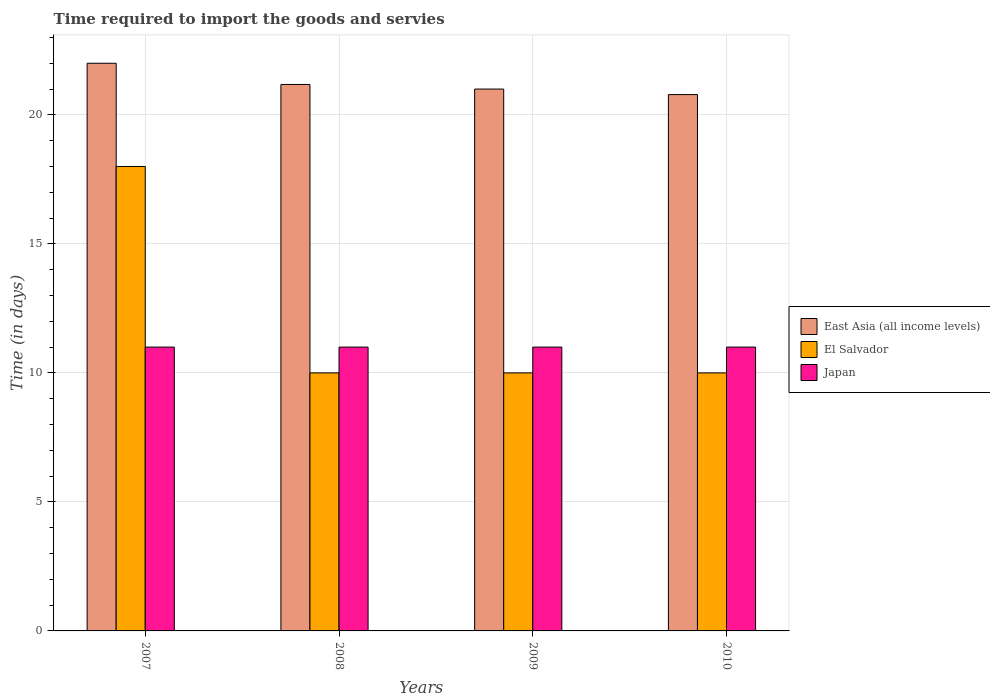How many groups of bars are there?
Offer a terse response. 4. Are the number of bars per tick equal to the number of legend labels?
Your response must be concise. Yes. Are the number of bars on each tick of the X-axis equal?
Offer a very short reply. Yes. How many bars are there on the 4th tick from the left?
Give a very brief answer. 3. How many bars are there on the 2nd tick from the right?
Your answer should be very brief. 3. Across all years, what is the maximum number of days required to import the goods and services in Japan?
Provide a succinct answer. 11. Across all years, what is the minimum number of days required to import the goods and services in Japan?
Give a very brief answer. 11. What is the total number of days required to import the goods and services in Japan in the graph?
Provide a succinct answer. 44. What is the difference between the number of days required to import the goods and services in El Salvador in 2008 and the number of days required to import the goods and services in Japan in 2007?
Provide a short and direct response. -1. What is the average number of days required to import the goods and services in El Salvador per year?
Offer a very short reply. 12. In the year 2010, what is the difference between the number of days required to import the goods and services in El Salvador and number of days required to import the goods and services in East Asia (all income levels)?
Provide a short and direct response. -10.79. In how many years, is the number of days required to import the goods and services in East Asia (all income levels) greater than 7 days?
Your answer should be very brief. 4. What is the ratio of the number of days required to import the goods and services in El Salvador in 2007 to that in 2010?
Offer a terse response. 1.8. What is the difference between the highest and the lowest number of days required to import the goods and services in El Salvador?
Provide a short and direct response. 8. In how many years, is the number of days required to import the goods and services in Japan greater than the average number of days required to import the goods and services in Japan taken over all years?
Make the answer very short. 0. What does the 2nd bar from the left in 2009 represents?
Your response must be concise. El Salvador. What does the 1st bar from the right in 2008 represents?
Keep it short and to the point. Japan. Is it the case that in every year, the sum of the number of days required to import the goods and services in East Asia (all income levels) and number of days required to import the goods and services in El Salvador is greater than the number of days required to import the goods and services in Japan?
Make the answer very short. Yes. How many bars are there?
Offer a terse response. 12. Are all the bars in the graph horizontal?
Provide a short and direct response. No. How many years are there in the graph?
Ensure brevity in your answer.  4. What is the difference between two consecutive major ticks on the Y-axis?
Ensure brevity in your answer.  5. Are the values on the major ticks of Y-axis written in scientific E-notation?
Give a very brief answer. No. Does the graph contain grids?
Provide a succinct answer. Yes. Where does the legend appear in the graph?
Keep it short and to the point. Center right. How are the legend labels stacked?
Offer a very short reply. Vertical. What is the title of the graph?
Your answer should be very brief. Time required to import the goods and servies. What is the label or title of the X-axis?
Make the answer very short. Years. What is the label or title of the Y-axis?
Ensure brevity in your answer.  Time (in days). What is the Time (in days) of East Asia (all income levels) in 2007?
Keep it short and to the point. 22. What is the Time (in days) in El Salvador in 2007?
Your response must be concise. 18. What is the Time (in days) in East Asia (all income levels) in 2008?
Ensure brevity in your answer.  21.18. What is the Time (in days) in Japan in 2008?
Your response must be concise. 11. What is the Time (in days) of East Asia (all income levels) in 2009?
Provide a succinct answer. 21. What is the Time (in days) in El Salvador in 2009?
Offer a terse response. 10. What is the Time (in days) of Japan in 2009?
Keep it short and to the point. 11. What is the Time (in days) in East Asia (all income levels) in 2010?
Keep it short and to the point. 20.79. What is the Time (in days) in El Salvador in 2010?
Your answer should be compact. 10. Across all years, what is the maximum Time (in days) in East Asia (all income levels)?
Provide a short and direct response. 22. Across all years, what is the maximum Time (in days) of El Salvador?
Offer a very short reply. 18. Across all years, what is the minimum Time (in days) in East Asia (all income levels)?
Your response must be concise. 20.79. What is the total Time (in days) of East Asia (all income levels) in the graph?
Give a very brief answer. 84.96. What is the difference between the Time (in days) in East Asia (all income levels) in 2007 and that in 2008?
Provide a succinct answer. 0.82. What is the difference between the Time (in days) in El Salvador in 2007 and that in 2008?
Keep it short and to the point. 8. What is the difference between the Time (in days) of Japan in 2007 and that in 2008?
Your response must be concise. 0. What is the difference between the Time (in days) in East Asia (all income levels) in 2007 and that in 2010?
Your response must be concise. 1.21. What is the difference between the Time (in days) in East Asia (all income levels) in 2008 and that in 2009?
Offer a very short reply. 0.18. What is the difference between the Time (in days) of East Asia (all income levels) in 2008 and that in 2010?
Give a very brief answer. 0.39. What is the difference between the Time (in days) in East Asia (all income levels) in 2009 and that in 2010?
Provide a succinct answer. 0.21. What is the difference between the Time (in days) in Japan in 2009 and that in 2010?
Provide a succinct answer. 0. What is the difference between the Time (in days) of East Asia (all income levels) in 2007 and the Time (in days) of El Salvador in 2009?
Your response must be concise. 12. What is the difference between the Time (in days) of East Asia (all income levels) in 2007 and the Time (in days) of Japan in 2009?
Your answer should be compact. 11. What is the difference between the Time (in days) in El Salvador in 2007 and the Time (in days) in Japan in 2009?
Offer a very short reply. 7. What is the difference between the Time (in days) in East Asia (all income levels) in 2008 and the Time (in days) in El Salvador in 2009?
Your response must be concise. 11.18. What is the difference between the Time (in days) of East Asia (all income levels) in 2008 and the Time (in days) of Japan in 2009?
Offer a terse response. 10.18. What is the difference between the Time (in days) of East Asia (all income levels) in 2008 and the Time (in days) of El Salvador in 2010?
Your answer should be compact. 11.18. What is the difference between the Time (in days) of East Asia (all income levels) in 2008 and the Time (in days) of Japan in 2010?
Provide a succinct answer. 10.18. What is the difference between the Time (in days) in El Salvador in 2008 and the Time (in days) in Japan in 2010?
Your answer should be very brief. -1. What is the difference between the Time (in days) of East Asia (all income levels) in 2009 and the Time (in days) of Japan in 2010?
Keep it short and to the point. 10. What is the difference between the Time (in days) of El Salvador in 2009 and the Time (in days) of Japan in 2010?
Keep it short and to the point. -1. What is the average Time (in days) of East Asia (all income levels) per year?
Your response must be concise. 21.24. In the year 2007, what is the difference between the Time (in days) of East Asia (all income levels) and Time (in days) of El Salvador?
Keep it short and to the point. 4. In the year 2007, what is the difference between the Time (in days) in East Asia (all income levels) and Time (in days) in Japan?
Ensure brevity in your answer.  11. In the year 2008, what is the difference between the Time (in days) of East Asia (all income levels) and Time (in days) of El Salvador?
Give a very brief answer. 11.18. In the year 2008, what is the difference between the Time (in days) in East Asia (all income levels) and Time (in days) in Japan?
Keep it short and to the point. 10.18. In the year 2009, what is the difference between the Time (in days) in El Salvador and Time (in days) in Japan?
Your answer should be very brief. -1. In the year 2010, what is the difference between the Time (in days) of East Asia (all income levels) and Time (in days) of El Salvador?
Make the answer very short. 10.79. In the year 2010, what is the difference between the Time (in days) of East Asia (all income levels) and Time (in days) of Japan?
Offer a terse response. 9.79. In the year 2010, what is the difference between the Time (in days) of El Salvador and Time (in days) of Japan?
Offer a terse response. -1. What is the ratio of the Time (in days) in East Asia (all income levels) in 2007 to that in 2008?
Your response must be concise. 1.04. What is the ratio of the Time (in days) of El Salvador in 2007 to that in 2008?
Make the answer very short. 1.8. What is the ratio of the Time (in days) in East Asia (all income levels) in 2007 to that in 2009?
Your answer should be very brief. 1.05. What is the ratio of the Time (in days) in Japan in 2007 to that in 2009?
Your answer should be very brief. 1. What is the ratio of the Time (in days) in East Asia (all income levels) in 2007 to that in 2010?
Offer a very short reply. 1.06. What is the ratio of the Time (in days) of Japan in 2007 to that in 2010?
Provide a succinct answer. 1. What is the ratio of the Time (in days) of East Asia (all income levels) in 2008 to that in 2009?
Ensure brevity in your answer.  1.01. What is the ratio of the Time (in days) of El Salvador in 2008 to that in 2009?
Your answer should be very brief. 1. What is the ratio of the Time (in days) in East Asia (all income levels) in 2008 to that in 2010?
Give a very brief answer. 1.02. What is the ratio of the Time (in days) in El Salvador in 2008 to that in 2010?
Offer a very short reply. 1. What is the ratio of the Time (in days) of East Asia (all income levels) in 2009 to that in 2010?
Your answer should be compact. 1.01. What is the ratio of the Time (in days) in El Salvador in 2009 to that in 2010?
Make the answer very short. 1. What is the ratio of the Time (in days) in Japan in 2009 to that in 2010?
Your answer should be very brief. 1. What is the difference between the highest and the second highest Time (in days) of East Asia (all income levels)?
Your response must be concise. 0.82. What is the difference between the highest and the lowest Time (in days) of East Asia (all income levels)?
Keep it short and to the point. 1.21. 